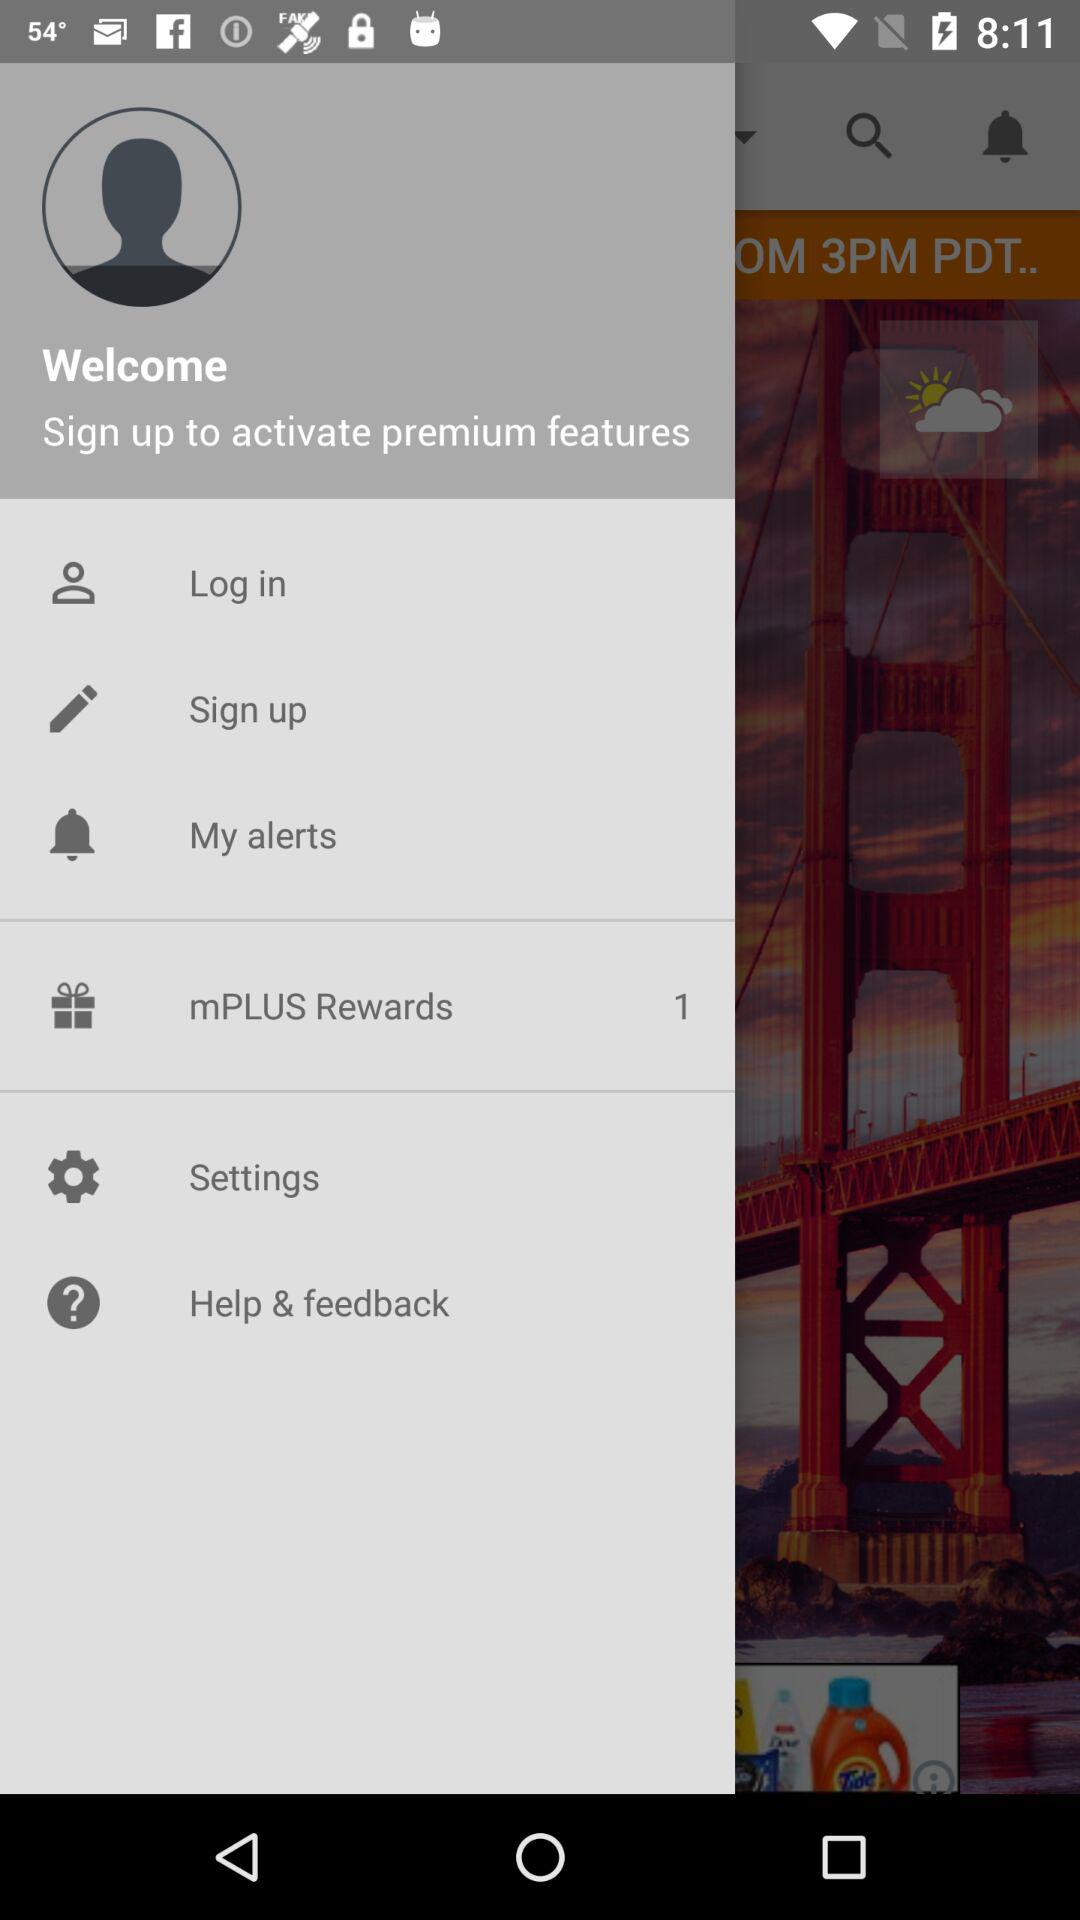For when are the alerts scheduled?
When the provided information is insufficient, respond with <no answer>. <no answer> 